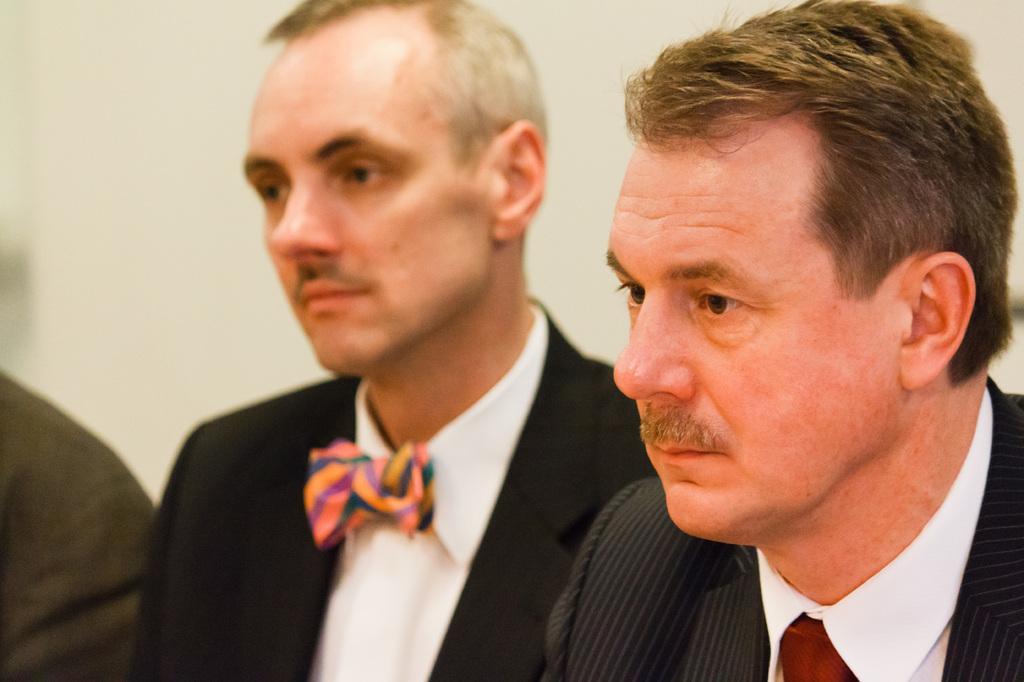Could you give a brief overview of what you see in this image? In this image in the foreground there are two persons and on the left side there is another person who are sitting, in the background there is a wall. 